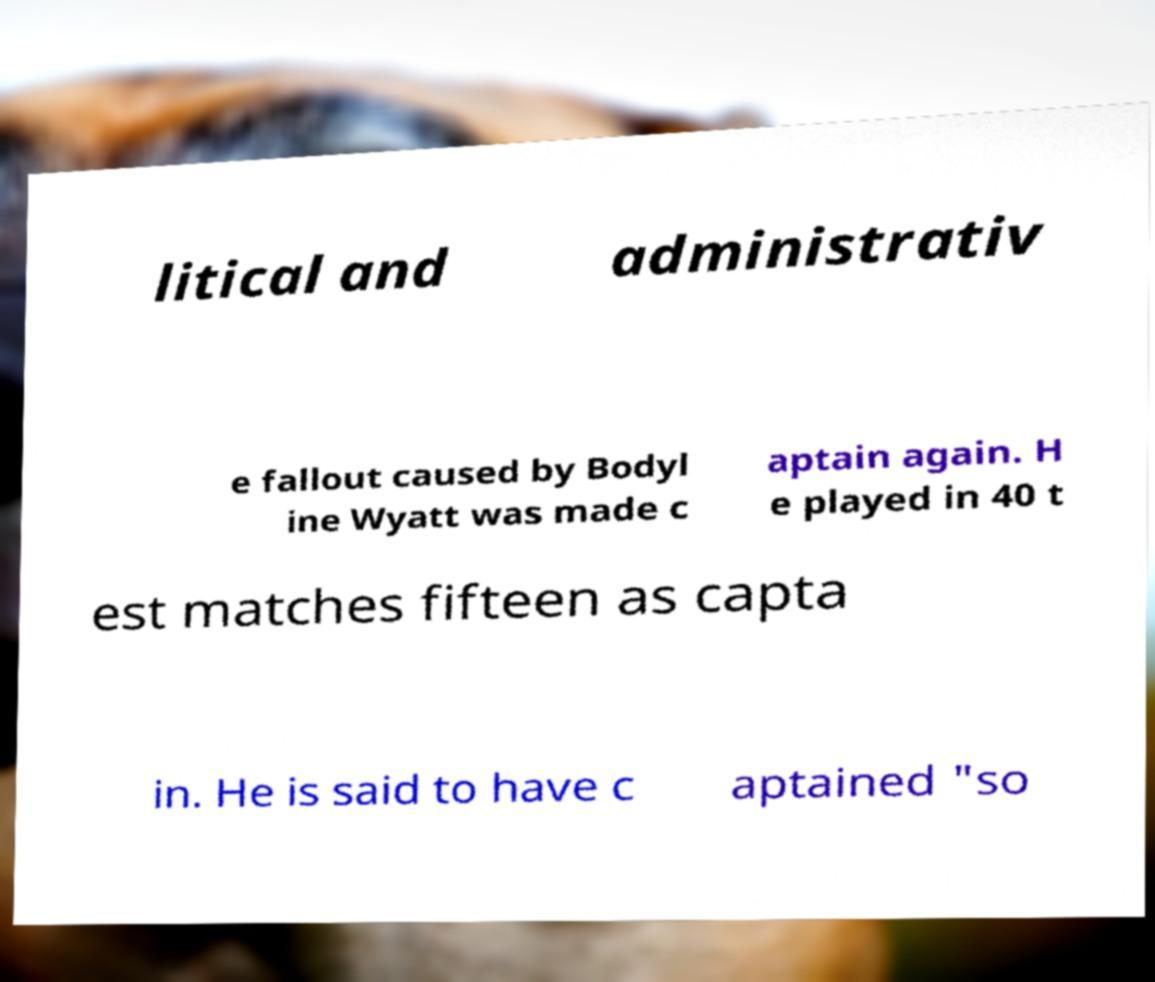I need the written content from this picture converted into text. Can you do that? litical and administrativ e fallout caused by Bodyl ine Wyatt was made c aptain again. H e played in 40 t est matches fifteen as capta in. He is said to have c aptained "so 